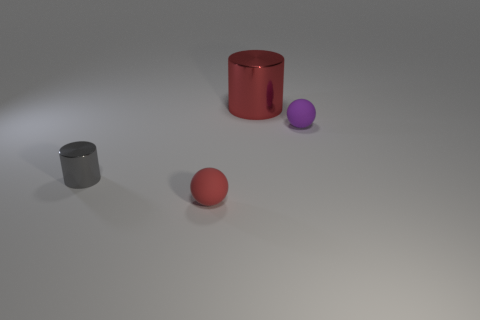Add 1 small red rubber objects. How many objects exist? 5 Subtract all gray metal cylinders. Subtract all tiny rubber objects. How many objects are left? 1 Add 2 small gray metal objects. How many small gray metal objects are left? 3 Add 1 small red shiny things. How many small red shiny things exist? 1 Subtract 1 red spheres. How many objects are left? 3 